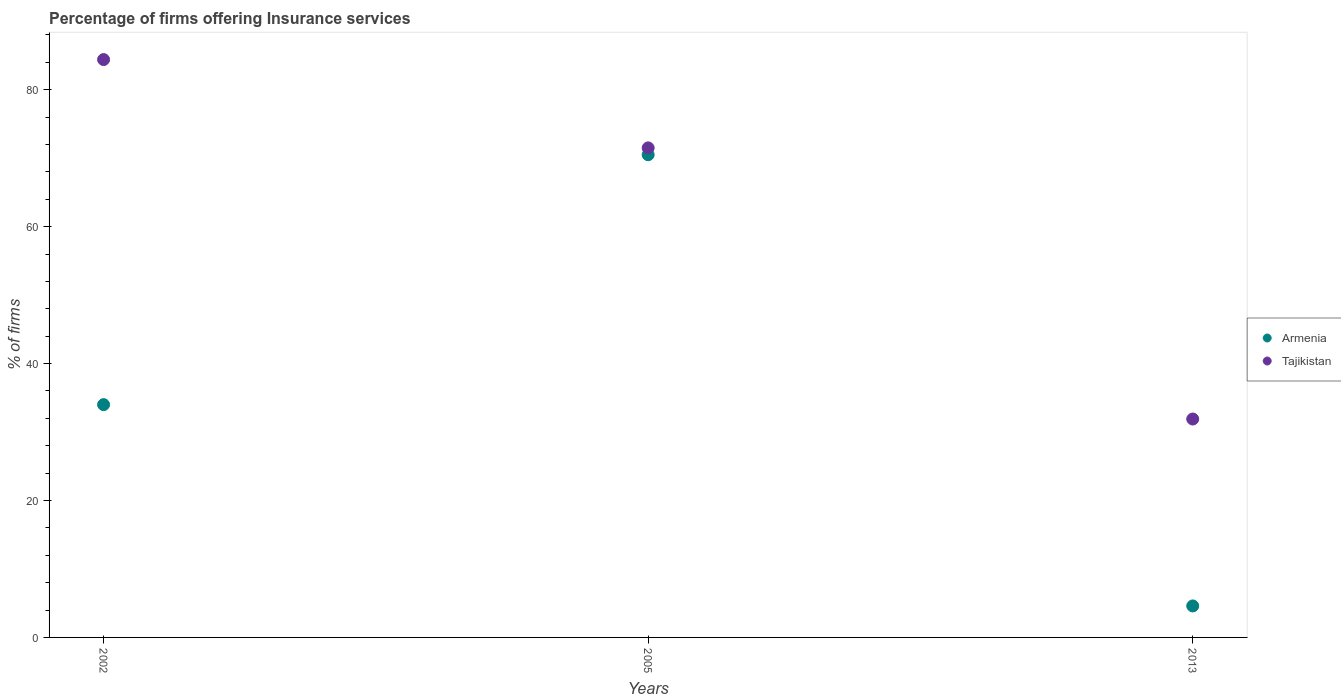Is the number of dotlines equal to the number of legend labels?
Give a very brief answer. Yes. What is the percentage of firms offering insurance services in Tajikistan in 2013?
Your answer should be very brief. 31.9. Across all years, what is the maximum percentage of firms offering insurance services in Tajikistan?
Make the answer very short. 84.4. Across all years, what is the minimum percentage of firms offering insurance services in Tajikistan?
Offer a terse response. 31.9. In which year was the percentage of firms offering insurance services in Armenia maximum?
Keep it short and to the point. 2005. In which year was the percentage of firms offering insurance services in Tajikistan minimum?
Your answer should be very brief. 2013. What is the total percentage of firms offering insurance services in Tajikistan in the graph?
Offer a very short reply. 187.8. What is the difference between the percentage of firms offering insurance services in Armenia in 2002 and that in 2005?
Your answer should be compact. -36.5. What is the difference between the percentage of firms offering insurance services in Tajikistan in 2002 and the percentage of firms offering insurance services in Armenia in 2013?
Keep it short and to the point. 79.8. What is the average percentage of firms offering insurance services in Tajikistan per year?
Offer a terse response. 62.6. In the year 2005, what is the difference between the percentage of firms offering insurance services in Armenia and percentage of firms offering insurance services in Tajikistan?
Give a very brief answer. -1. In how many years, is the percentage of firms offering insurance services in Tajikistan greater than 8 %?
Offer a very short reply. 3. What is the ratio of the percentage of firms offering insurance services in Armenia in 2005 to that in 2013?
Ensure brevity in your answer.  15.33. What is the difference between the highest and the second highest percentage of firms offering insurance services in Tajikistan?
Ensure brevity in your answer.  12.9. What is the difference between the highest and the lowest percentage of firms offering insurance services in Tajikistan?
Make the answer very short. 52.5. Does the percentage of firms offering insurance services in Tajikistan monotonically increase over the years?
Your answer should be compact. No. Is the percentage of firms offering insurance services in Armenia strictly greater than the percentage of firms offering insurance services in Tajikistan over the years?
Your response must be concise. No. How many dotlines are there?
Ensure brevity in your answer.  2. Where does the legend appear in the graph?
Your answer should be compact. Center right. What is the title of the graph?
Your response must be concise. Percentage of firms offering Insurance services. What is the label or title of the Y-axis?
Give a very brief answer. % of firms. What is the % of firms in Armenia in 2002?
Ensure brevity in your answer.  34. What is the % of firms in Tajikistan in 2002?
Give a very brief answer. 84.4. What is the % of firms of Armenia in 2005?
Your answer should be compact. 70.5. What is the % of firms of Tajikistan in 2005?
Give a very brief answer. 71.5. What is the % of firms of Tajikistan in 2013?
Offer a terse response. 31.9. Across all years, what is the maximum % of firms in Armenia?
Your answer should be very brief. 70.5. Across all years, what is the maximum % of firms of Tajikistan?
Provide a short and direct response. 84.4. Across all years, what is the minimum % of firms of Tajikistan?
Provide a succinct answer. 31.9. What is the total % of firms of Armenia in the graph?
Offer a terse response. 109.1. What is the total % of firms of Tajikistan in the graph?
Your answer should be compact. 187.8. What is the difference between the % of firms of Armenia in 2002 and that in 2005?
Give a very brief answer. -36.5. What is the difference between the % of firms in Armenia in 2002 and that in 2013?
Provide a succinct answer. 29.4. What is the difference between the % of firms in Tajikistan in 2002 and that in 2013?
Provide a succinct answer. 52.5. What is the difference between the % of firms of Armenia in 2005 and that in 2013?
Provide a short and direct response. 65.9. What is the difference between the % of firms of Tajikistan in 2005 and that in 2013?
Give a very brief answer. 39.6. What is the difference between the % of firms in Armenia in 2002 and the % of firms in Tajikistan in 2005?
Your response must be concise. -37.5. What is the difference between the % of firms of Armenia in 2005 and the % of firms of Tajikistan in 2013?
Keep it short and to the point. 38.6. What is the average % of firms of Armenia per year?
Give a very brief answer. 36.37. What is the average % of firms in Tajikistan per year?
Ensure brevity in your answer.  62.6. In the year 2002, what is the difference between the % of firms in Armenia and % of firms in Tajikistan?
Make the answer very short. -50.4. In the year 2013, what is the difference between the % of firms in Armenia and % of firms in Tajikistan?
Ensure brevity in your answer.  -27.3. What is the ratio of the % of firms in Armenia in 2002 to that in 2005?
Provide a succinct answer. 0.48. What is the ratio of the % of firms in Tajikistan in 2002 to that in 2005?
Offer a very short reply. 1.18. What is the ratio of the % of firms of Armenia in 2002 to that in 2013?
Provide a succinct answer. 7.39. What is the ratio of the % of firms of Tajikistan in 2002 to that in 2013?
Make the answer very short. 2.65. What is the ratio of the % of firms of Armenia in 2005 to that in 2013?
Your answer should be very brief. 15.33. What is the ratio of the % of firms in Tajikistan in 2005 to that in 2013?
Provide a succinct answer. 2.24. What is the difference between the highest and the second highest % of firms of Armenia?
Keep it short and to the point. 36.5. What is the difference between the highest and the second highest % of firms of Tajikistan?
Ensure brevity in your answer.  12.9. What is the difference between the highest and the lowest % of firms of Armenia?
Your answer should be very brief. 65.9. What is the difference between the highest and the lowest % of firms of Tajikistan?
Your answer should be very brief. 52.5. 